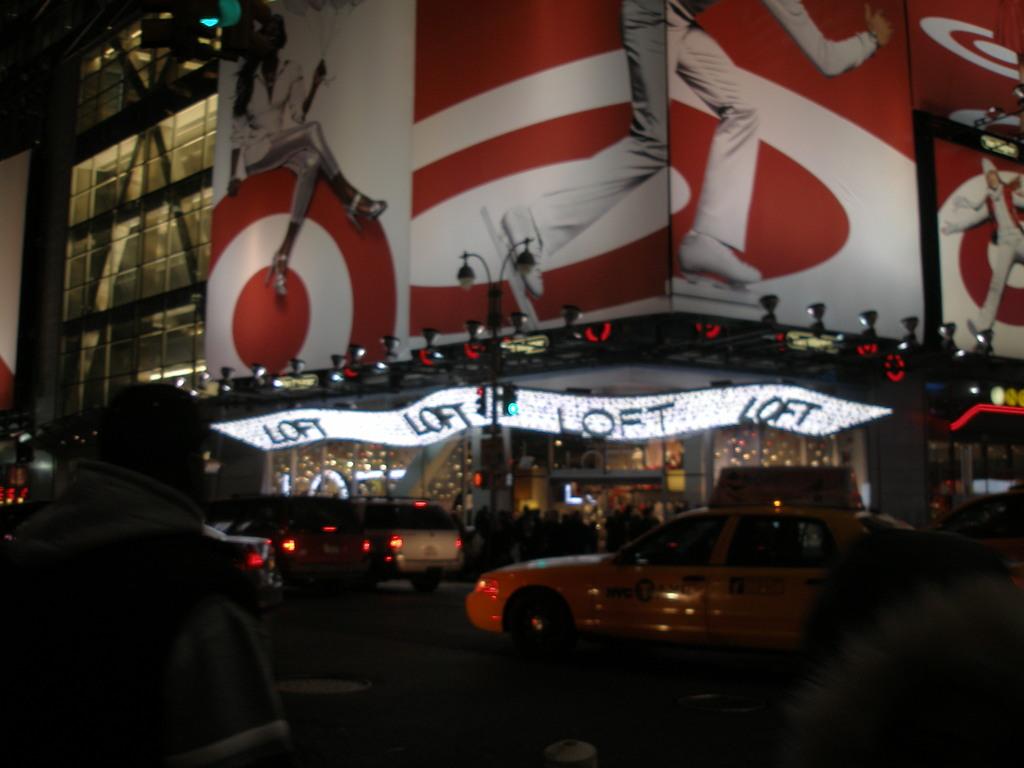What is the name of the business?
Provide a short and direct response. Loft. What kind of car is the yellow one?
Give a very brief answer. Taxi. 